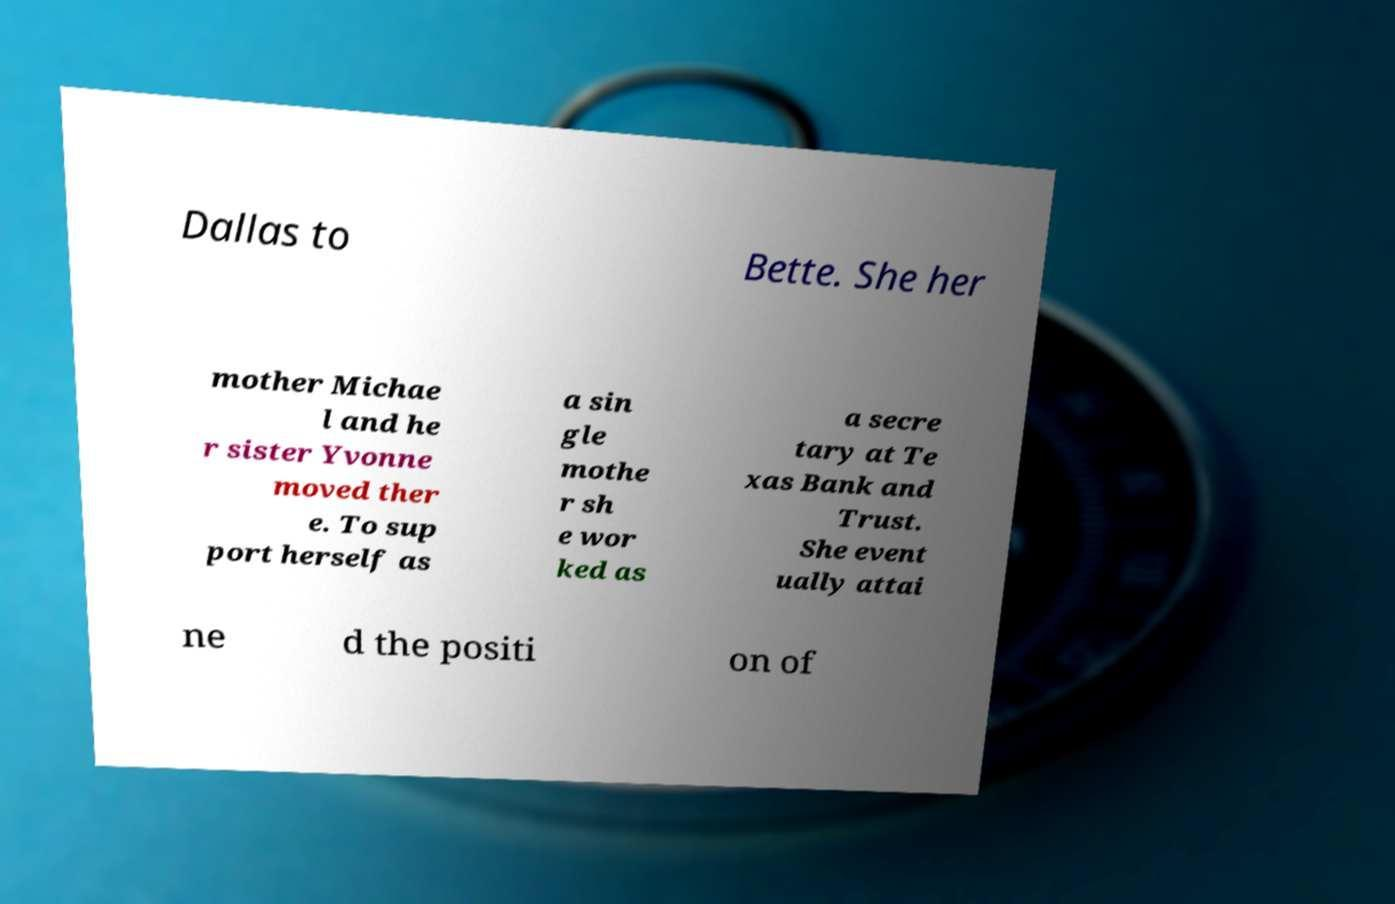Can you read and provide the text displayed in the image?This photo seems to have some interesting text. Can you extract and type it out for me? Dallas to Bette. She her mother Michae l and he r sister Yvonne moved ther e. To sup port herself as a sin gle mothe r sh e wor ked as a secre tary at Te xas Bank and Trust. She event ually attai ne d the positi on of 